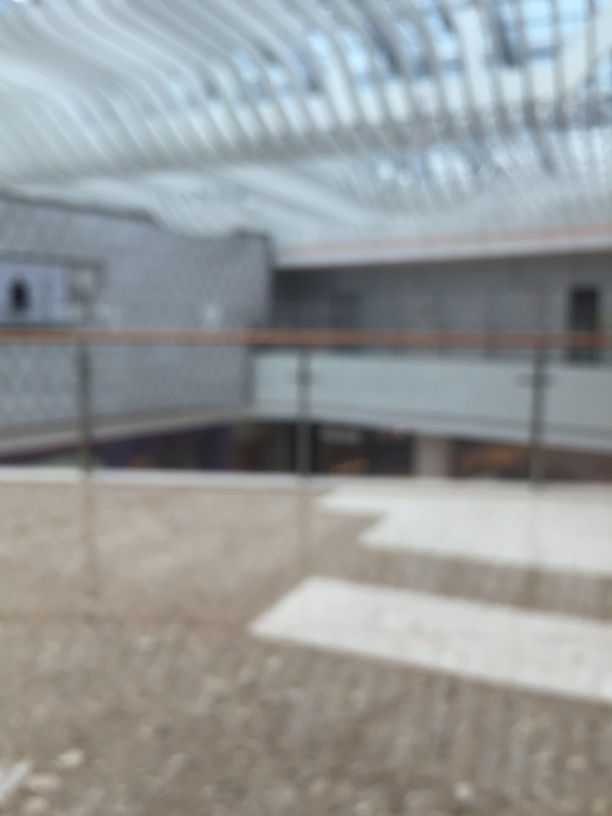What potential purposes could this structure serve, based on its design and layout as observed in the image? Based on the open layout and the grand scale indicated by the roof structure, this space could be intended for public use, such as a shopping mall, airport terminal, or convention center. These types of establishments typically require large, open spaces without many internal obstructions to accommodate high foot traffic and a variety of installations or events. What modifications would enhance the utility of this space? Improving utility could involve installing clear signage for navigation, incorporating flexible seating areas, ensuring ample lighting for visibility and ambiance, and integrating green spaces for aesthetic and environmental benefits. The addition of technological amenities like charging stations and interactive information screens would also be beneficial in a modern public space. 